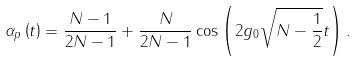<formula> <loc_0><loc_0><loc_500><loc_500>\alpha _ { p } \left ( t \right ) = \frac { N - 1 } { 2 N - 1 } + \frac { N } { 2 N - 1 } \cos \left ( 2 g _ { 0 } \sqrt { N - \frac { 1 } { 2 } } t \right ) .</formula> 